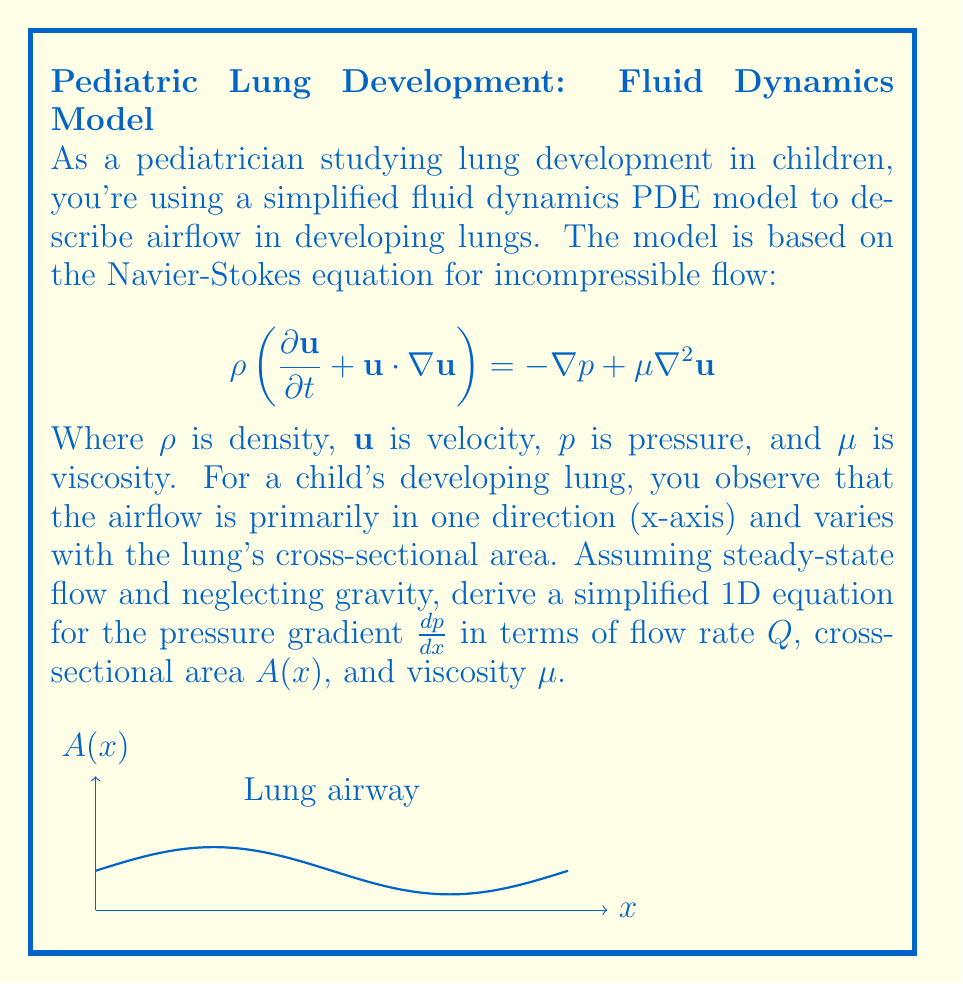What is the answer to this math problem? Let's approach this step-by-step:

1) First, we simplify the Navier-Stokes equation for our scenario:
   - Steady-state flow means $\frac{\partial \mathbf{u}}{\partial t} = 0$
   - 1D flow means $\mathbf{u} = (u(x), 0, 0)$
   - Incompressibility implies $\nabla \cdot \mathbf{u} = \frac{\partial u}{\partial x} = 0$

2) The simplified equation becomes:

   $$\rho u \frac{du}{dx} = -\frac{dp}{dx} + \mu \frac{d^2u}{dx^2}$$

3) From the continuity equation for incompressible flow:
   
   $$Q = uA(x)$$

   where $Q$ is the constant flow rate.

4) Differentiating this with respect to $x$:

   $$0 = A(x)\frac{du}{dx} + u\frac{dA}{dx}$$

5) Solving for $\frac{du}{dx}$:

   $$\frac{du}{dx} = -\frac{u}{A}\frac{dA}{dx}$$

6) Differentiating again:

   $$\frac{d^2u}{dx^2} = -\frac{1}{A}\frac{dA}{dx}\frac{du}{dx} + \frac{u}{A^2}\left(\frac{dA}{dx}\right)^2 - \frac{u}{A}\frac{d^2A}{dx^2}$$

7) Substituting these into our simplified Navier-Stokes equation:

   $$\rho u \left(-\frac{u}{A}\frac{dA}{dx}\right) = -\frac{dp}{dx} + \mu \left(-\frac{1}{A}\frac{dA}{dx}\frac{du}{dx} + \frac{u}{A^2}\left(\frac{dA}{dx}\right)^2 - \frac{u}{A}\frac{d^2A}{dx^2}\right)$$

8) Substituting $u = \frac{Q}{A}$ and simplifying:

   $$\frac{\rho Q^2}{A^3}\frac{dA}{dx} = -\frac{dp}{dx} + \mu \left(\frac{Q}{A^3}\left(\frac{dA}{dx}\right)^2 - \frac{Q}{A^2}\frac{d^2A}{dx^2}\right)$$

9) Rearranging to isolate $\frac{dp}{dx}$:

   $$\frac{dp}{dx} = -\frac{\rho Q^2}{A^3}\frac{dA}{dx} + \mu \left(\frac{Q}{A^3}\left(\frac{dA}{dx}\right)^2 - \frac{Q}{A^2}\frac{d^2A}{dx^2}\right)$$

This is our final simplified equation for the pressure gradient in terms of $Q$, $A(x)$, and $\mu$.
Answer: $$\frac{dp}{dx} = -\frac{\rho Q^2}{A^3}\frac{dA}{dx} + \mu \left(\frac{Q}{A^3}\left(\frac{dA}{dx}\right)^2 - \frac{Q}{A^2}\frac{d^2A}{dx^2}\right)$$ 